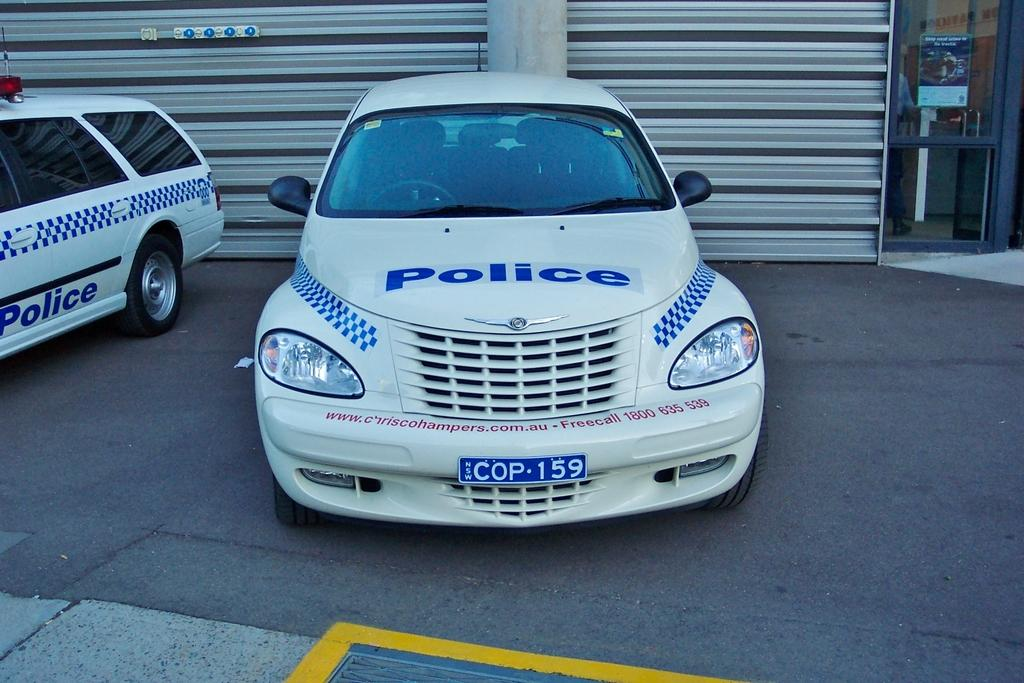<image>
Write a terse but informative summary of the picture. A PT cruiser used as a police car with license plate COP159. 